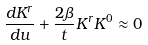Convert formula to latex. <formula><loc_0><loc_0><loc_500><loc_500>\frac { d K ^ { r } } { d u } + \frac { 2 \beta } { t } K ^ { r } K ^ { 0 } \approx 0</formula> 